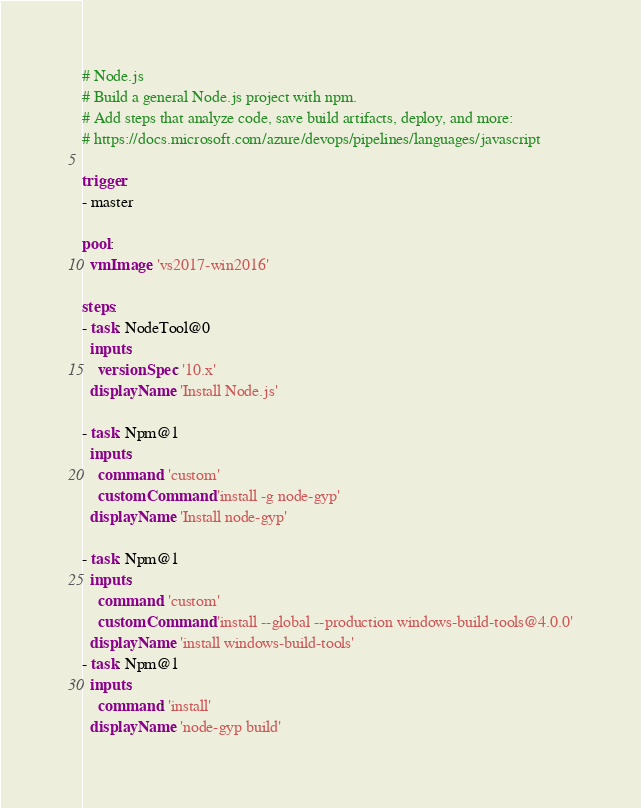<code> <loc_0><loc_0><loc_500><loc_500><_YAML_>
# Node.js
# Build a general Node.js project with npm.
# Add steps that analyze code, save build artifacts, deploy, and more:
# https://docs.microsoft.com/azure/devops/pipelines/languages/javascript

trigger:
- master

pool:
  vmImage: 'vs2017-win2016'

steps:
- task: NodeTool@0
  inputs:
    versionSpec: '10.x'
  displayName: 'Install Node.js'

- task: Npm@1
  inputs:
    command: 'custom'
    customCommand: 'install -g node-gyp'
  displayName: 'Install node-gyp'

- task: Npm@1
  inputs:
    command: 'custom'
    customCommand: 'install --global --production windows-build-tools@4.0.0'
  displayName: 'install windows-build-tools'
- task: Npm@1
  inputs:
    command: 'install'
  displayName: 'node-gyp build'</code> 